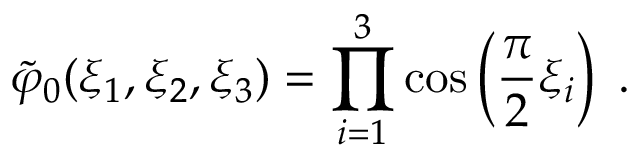<formula> <loc_0><loc_0><loc_500><loc_500>\tilde { \varphi } _ { 0 } ( \xi _ { 1 } , \xi _ { 2 } , \xi _ { 3 } ) = \prod _ { i = 1 } ^ { 3 } \cos \left ( \frac { \pi } { 2 } \xi _ { i } \right ) \, .</formula> 